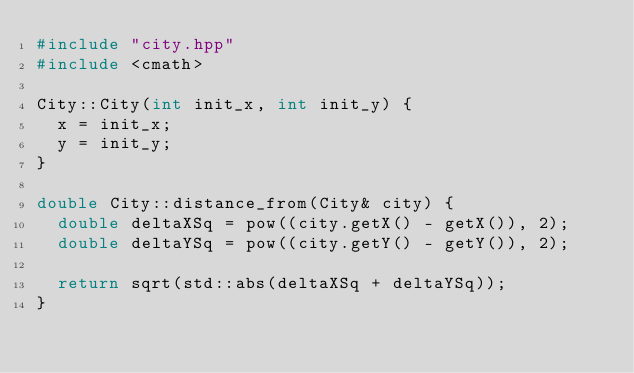Convert code to text. <code><loc_0><loc_0><loc_500><loc_500><_C++_>#include "city.hpp"
#include <cmath>

City::City(int init_x, int init_y) {
  x = init_x;
  y = init_y;
}

double City::distance_from(City& city) {
  double deltaXSq = pow((city.getX() - getX()), 2);
  double deltaYSq = pow((city.getY() - getY()), 2);

  return sqrt(std::abs(deltaXSq + deltaYSq));
}
</code> 